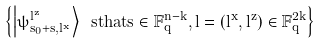Convert formula to latex. <formula><loc_0><loc_0><loc_500><loc_500>\left \{ \left | \psi _ { \vec { s } _ { 0 } + \vec { s } , \vec { l } ^ { x } } ^ { \vec { l } ^ { z } } \right \rangle \ s t h a t \vec { s } \in \mathbb { F } _ { q } ^ { n - k } , \vec { l } = ( \vec { l } ^ { x } , \vec { l } ^ { z } ) \in \mathbb { F } _ { q } ^ { 2 k } \right \}</formula> 